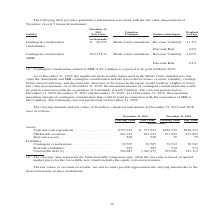According to Teradyne's financial document, What does the carrying value of convertible debt represent? the bifurcated debt component only, while the fair value is based on quoted market prices for the convertible note which includes the equity conversion features.. The document states: "(1) The carrying value represents the bifurcated debt component only, while the fair value is based on quoted market prices for the convertible note w..." Also, What do the fair values of accounts receivable, net and accounts payable approximate? the carrying amount due to the short term nature of these instruments. The document states: "receivable, net and accounts payable approximate the carrying amount due to the short term nature of these instruments...." Also, In which years were the carrying amounts and fair values of Teradyne’s financial instruments recorded? The document shows two values: 2019 and 2018. From the document: "December 31, 2019 December 31, 2018 December 31, 2019 December 31, 2018..." Additionally, In which year was the fair value of Derivative assets larger? According to the financial document, 2019. The relevant text states: "December 31, 2019 December 31, 2018..." Also, can you calculate: What was the change in the fair value of Marketable securities from 2018 to 2019? Based on the calculation: 241,793-277,827, the result is -36034 (in thousands). This is based on the information: "$926,752 Marketable securities . 241,793 241,793 277,827 277,827 Derivative assets . 528 528 79 79 Liabilities Contingent consideration . 39,705 39,705 70,5 773,924 $926,752 $926,752 Marketable securi..." The key data points involved are: 241,793, 277,827. Also, can you calculate: What was the percentage change in the fair value of Marketable securities from 2018 to 2019? To answer this question, I need to perform calculations using the financial data. The calculation is: (241,793-277,827)/277,827, which equals -12.97 (percentage). This is based on the information: "$926,752 Marketable securities . 241,793 241,793 277,827 277,827 Derivative assets . 528 528 79 79 Liabilities Contingent consideration . 39,705 39,705 70,5 773,924 $926,752 $926,752 Marketable securi..." The key data points involved are: 241,793, 277,827. 